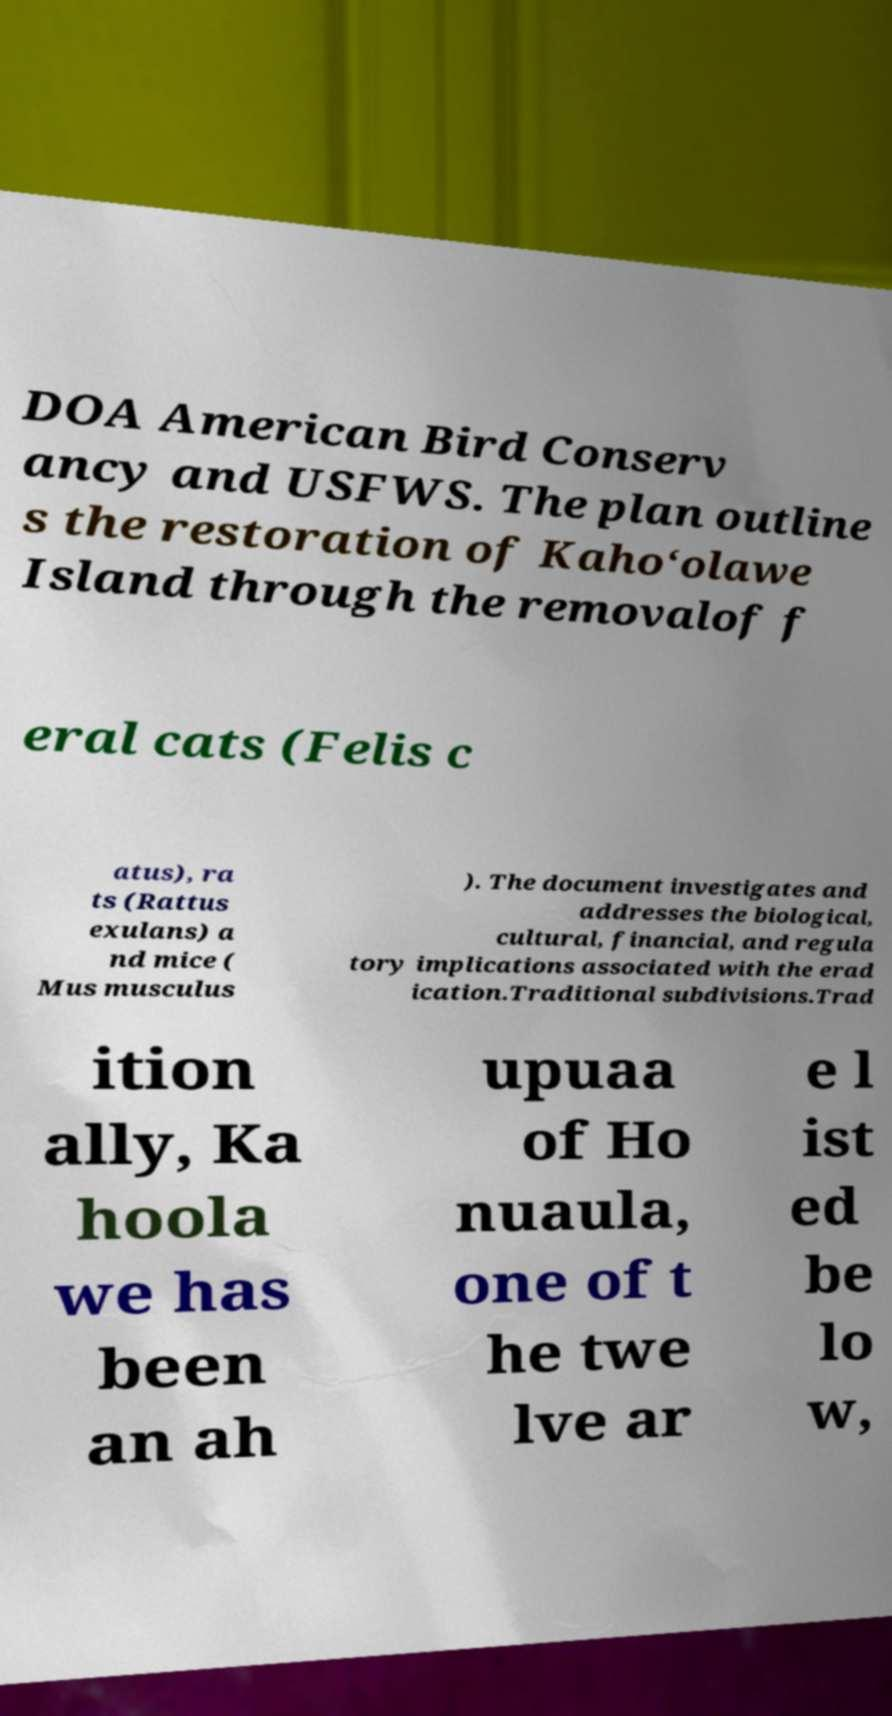Could you extract and type out the text from this image? DOA American Bird Conserv ancy and USFWS. The plan outline s the restoration of Kaho‘olawe Island through the removalof f eral cats (Felis c atus), ra ts (Rattus exulans) a nd mice ( Mus musculus ). The document investigates and addresses the biological, cultural, financial, and regula tory implications associated with the erad ication.Traditional subdivisions.Trad ition ally, Ka hoola we has been an ah upuaa of Ho nuaula, one of t he twe lve ar e l ist ed be lo w, 